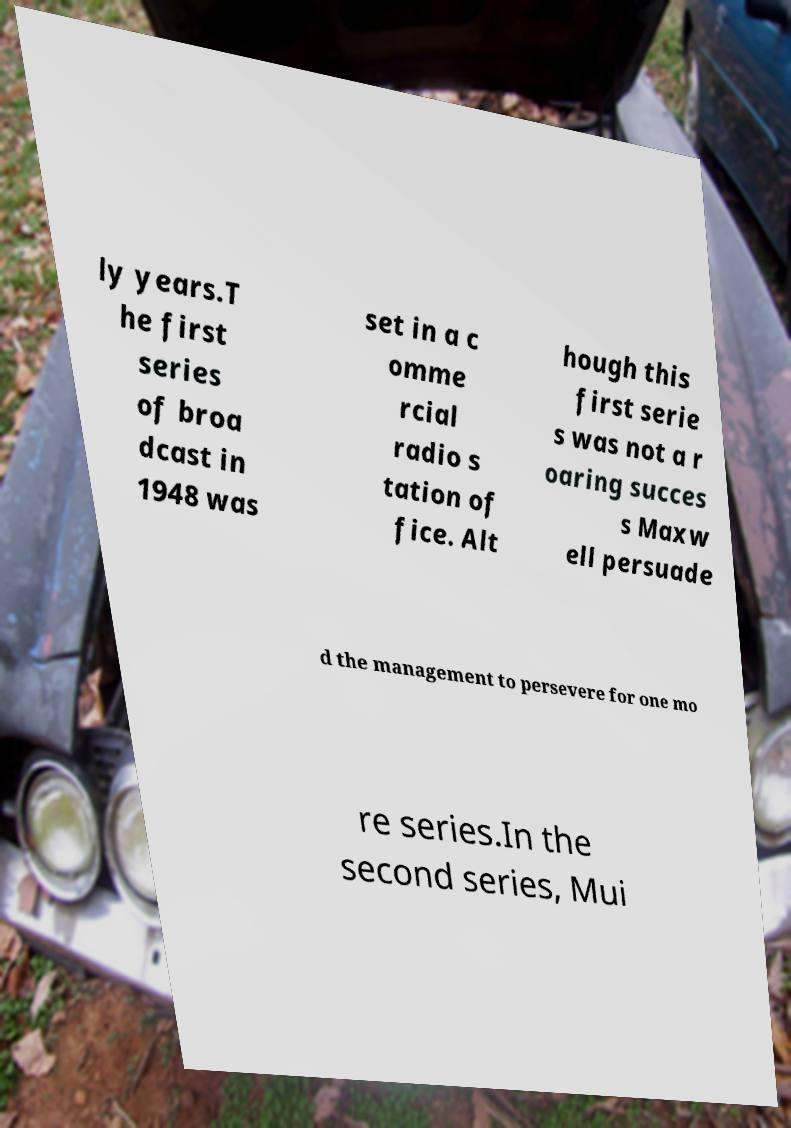For documentation purposes, I need the text within this image transcribed. Could you provide that? ly years.T he first series of broa dcast in 1948 was set in a c omme rcial radio s tation of fice. Alt hough this first serie s was not a r oaring succes s Maxw ell persuade d the management to persevere for one mo re series.In the second series, Mui 